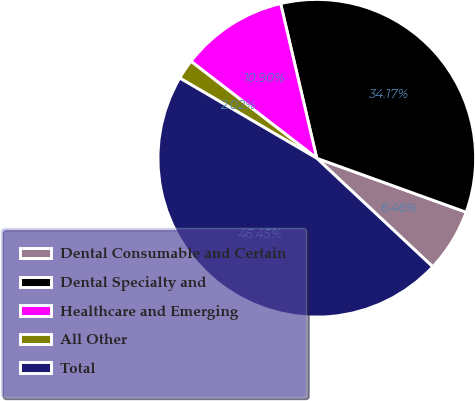Convert chart. <chart><loc_0><loc_0><loc_500><loc_500><pie_chart><fcel>Dental Consumable and Certain<fcel>Dental Specialty and<fcel>Healthcare and Emerging<fcel>All Other<fcel>Total<nl><fcel>6.46%<fcel>34.17%<fcel>10.9%<fcel>2.02%<fcel>46.45%<nl></chart> 